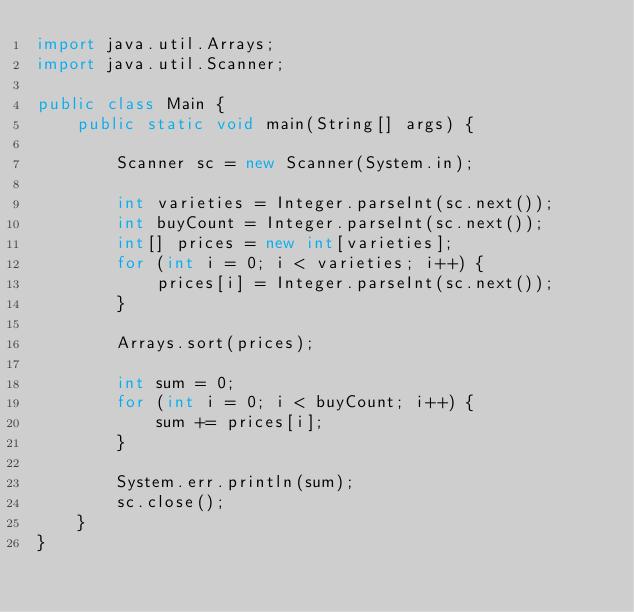Convert code to text. <code><loc_0><loc_0><loc_500><loc_500><_Java_>import java.util.Arrays;
import java.util.Scanner;

public class Main {
    public static void main(String[] args) {

        Scanner sc = new Scanner(System.in);

        int varieties = Integer.parseInt(sc.next());
        int buyCount = Integer.parseInt(sc.next());
        int[] prices = new int[varieties];
        for (int i = 0; i < varieties; i++) {
            prices[i] = Integer.parseInt(sc.next());
        }

        Arrays.sort(prices);

        int sum = 0;
        for (int i = 0; i < buyCount; i++) {
            sum += prices[i];
        }

        System.err.println(sum);
        sc.close();
    }
}
</code> 